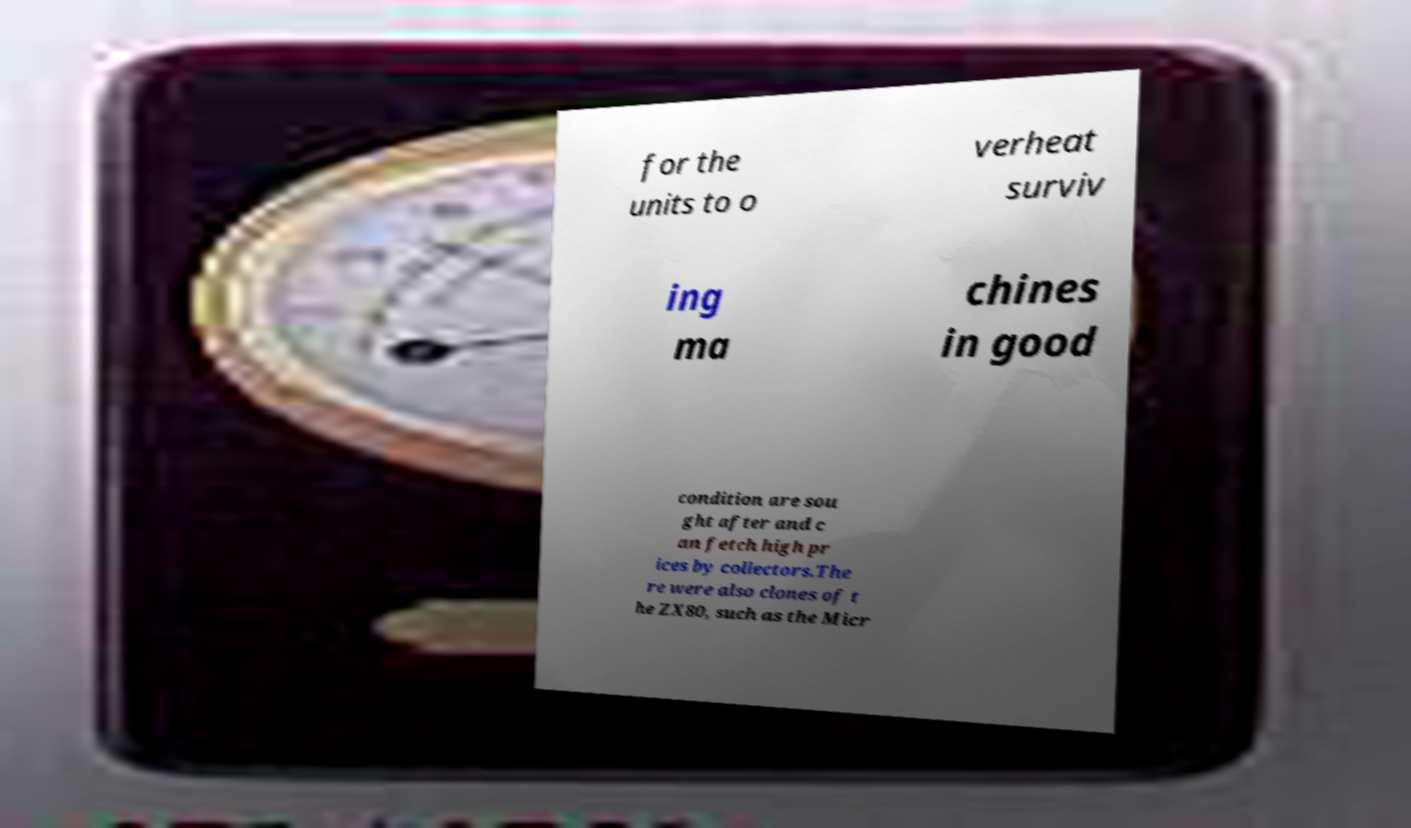Can you accurately transcribe the text from the provided image for me? for the units to o verheat surviv ing ma chines in good condition are sou ght after and c an fetch high pr ices by collectors.The re were also clones of t he ZX80, such as the Micr 